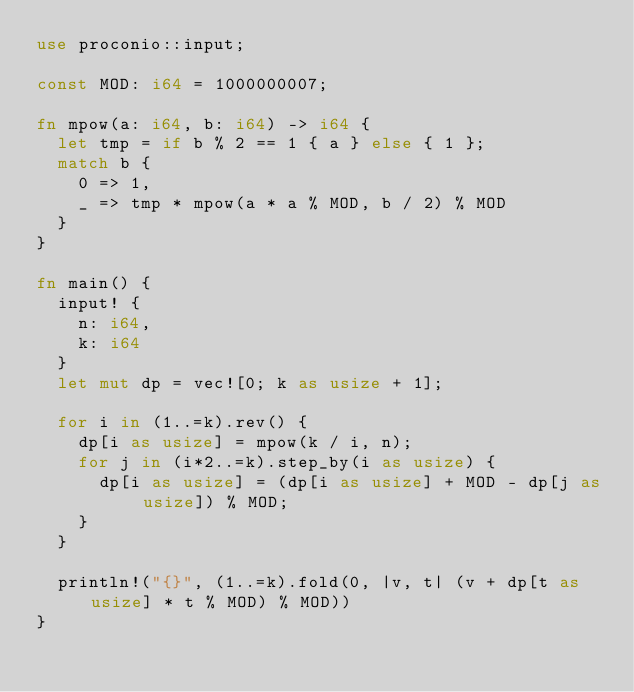Convert code to text. <code><loc_0><loc_0><loc_500><loc_500><_Rust_>use proconio::input;

const MOD: i64 = 1000000007;

fn mpow(a: i64, b: i64) -> i64 {
  let tmp = if b % 2 == 1 { a } else { 1 };
  match b {
    0 => 1,
    _ => tmp * mpow(a * a % MOD, b / 2) % MOD
  }
}

fn main() {
  input! {
    n: i64,
    k: i64
  }
  let mut dp = vec![0; k as usize + 1];
  
  for i in (1..=k).rev() {
    dp[i as usize] = mpow(k / i, n);
    for j in (i*2..=k).step_by(i as usize) {
      dp[i as usize] = (dp[i as usize] + MOD - dp[j as usize]) % MOD;
    }
  }
  
  println!("{}", (1..=k).fold(0, |v, t| (v + dp[t as usize] * t % MOD) % MOD))
}

</code> 